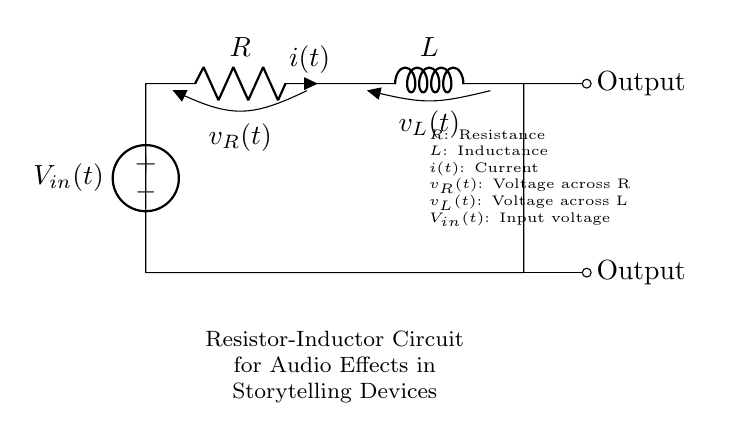What is the input voltage source labeled? The input voltage source in the circuit is labeled as V_in(t), indicating it is a time-dependent voltage source.
Answer: V_in(t) How many outputs does the circuit have? The circuit has two outputs, as seen at the right side where "Output" is indicated for both the top and bottom paths.
Answer: Two What component is directly connected to the current i(t)? The current i(t) is directly associated with the resistor, as indicated by the label in the diagram showing the current flowing through it.
Answer: Resistor What is the voltage across the inductor labeled as? The voltage across the inductor is labeled as v_L(t), which reflects the potential difference across the inductive component in the circuit.
Answer: v_L(t) If you increase the resistance, what will happen to the current? Increasing the resistance will decrease the current, as per Ohm's law which states that current is inversely proportional to resistance when voltage is constant.
Answer: Decrease Which component stores energy in this circuit? The inductor is the component that stores energy in the magnetic field when current flows through it.
Answer: Inductor What does the letter L represent in the circuit? The letter L represents inductance, which quantifies how effectively an inductor can store energy in a magnetic field.
Answer: Inductance 